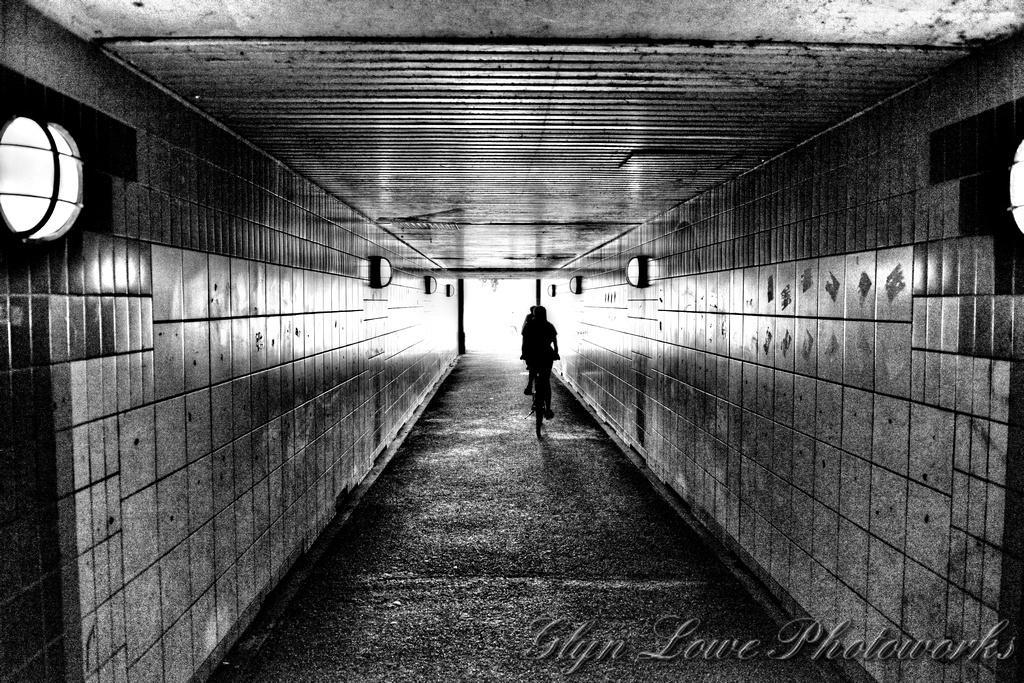In one or two sentences, can you explain what this image depicts? The image is in black and white, we can see there is a person riding a bicycle, there is a wall, there is a roof. 